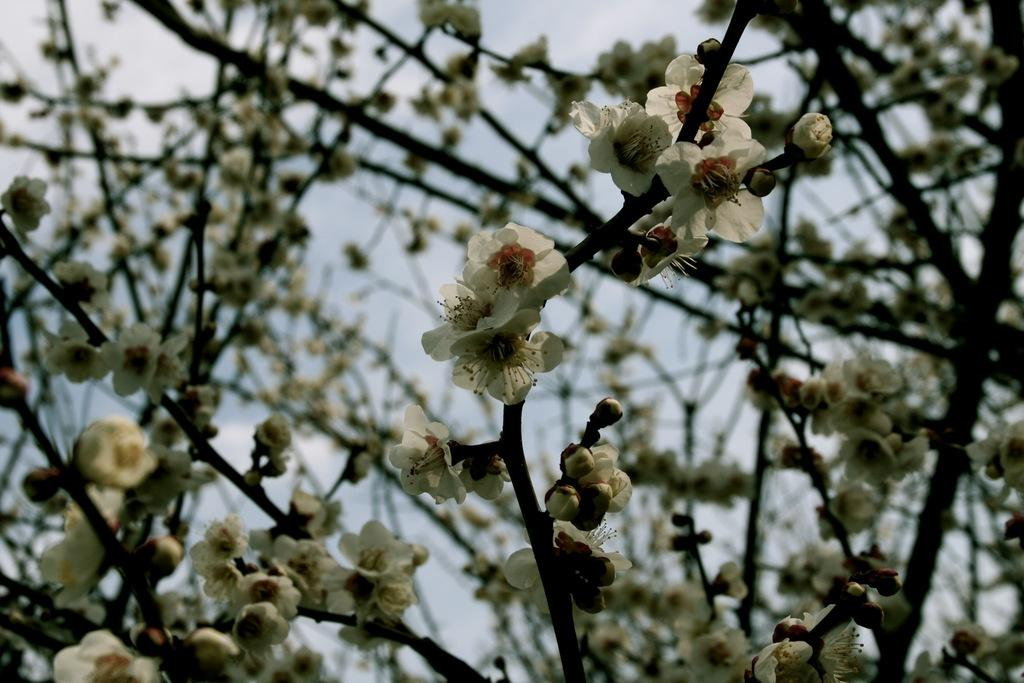What type of flowers can be seen in the image? There are white flowers in the image. Where are the flowers located? The flowers are on the branches of a tree. What flavor of cake is being served at the event in the image? There is no cake or event present in the image; it only features white flowers on the branches of a tree. 